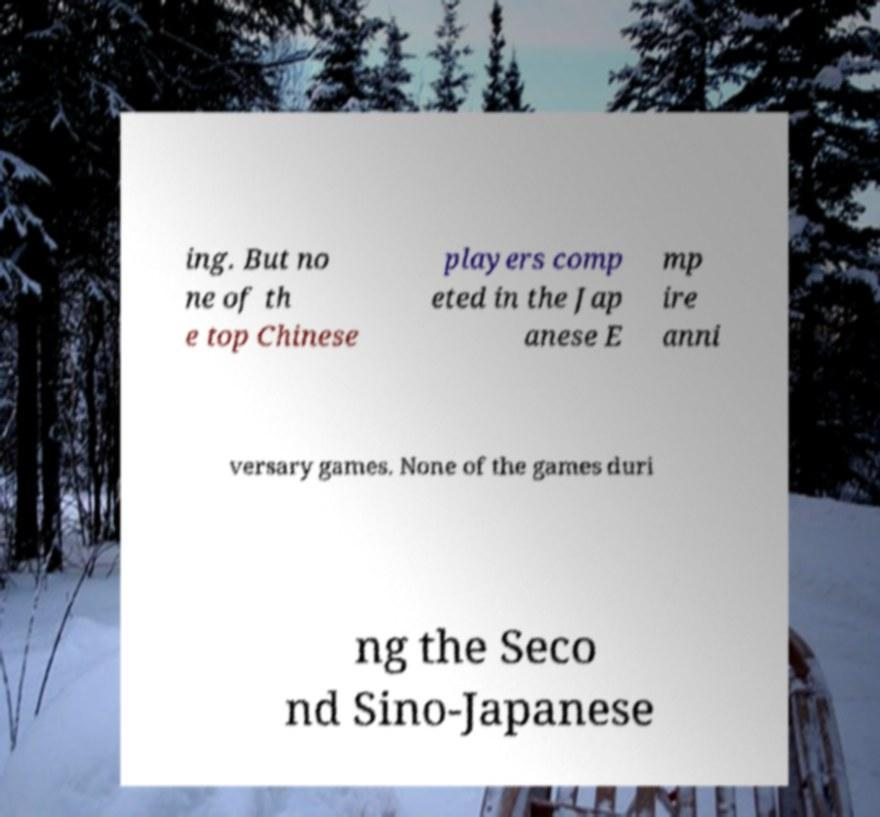Can you read and provide the text displayed in the image?This photo seems to have some interesting text. Can you extract and type it out for me? ing. But no ne of th e top Chinese players comp eted in the Jap anese E mp ire anni versary games. None of the games duri ng the Seco nd Sino-Japanese 